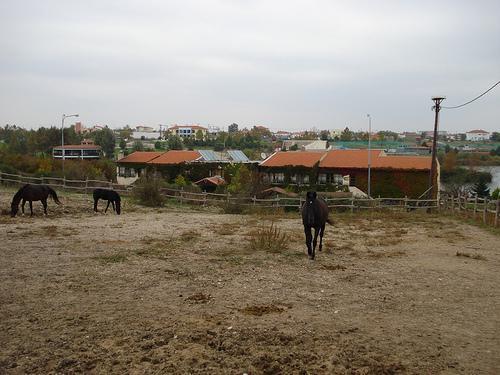How many horses in this photo?
Give a very brief answer. 3. 